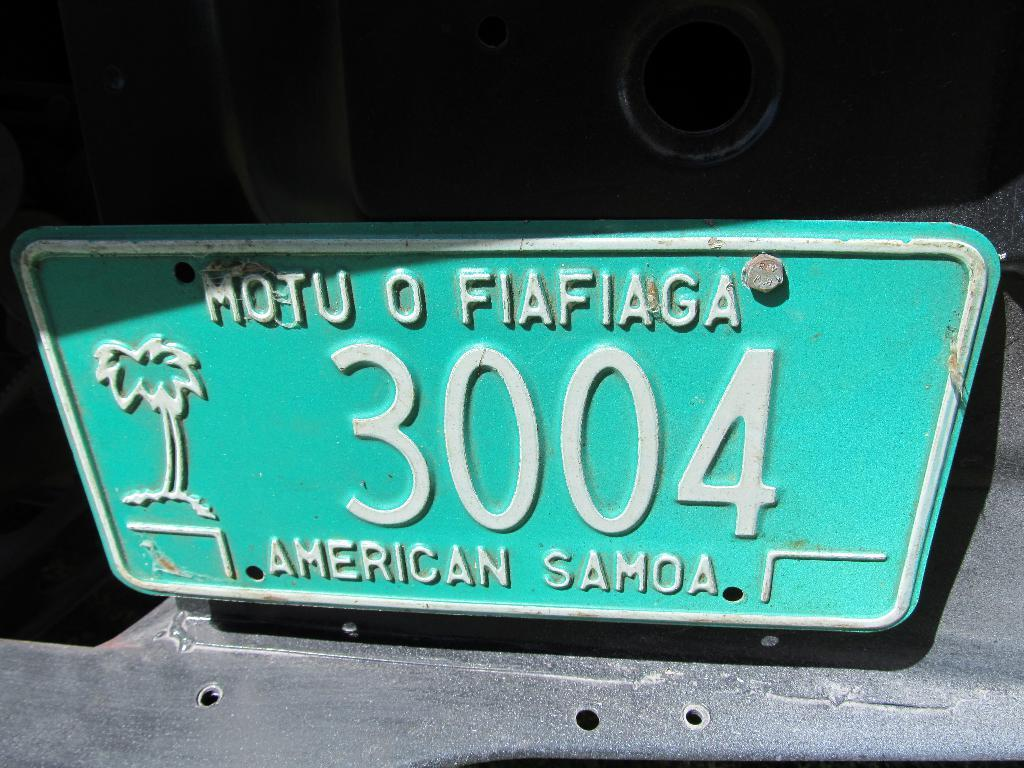<image>
Give a short and clear explanation of the subsequent image. a closeup of a license plate reading Motu O Fiafiaga 